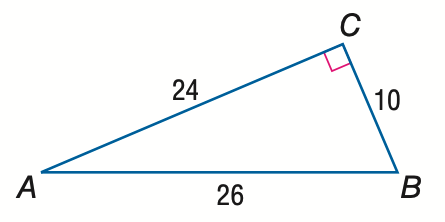Answer the mathemtical geometry problem and directly provide the correct option letter.
Question: Express the ratio of \tan A as a decimal to the nearest hundredth.
Choices: A: 0.38 B: 0.42 C: 0.92 D: 2.40 B 